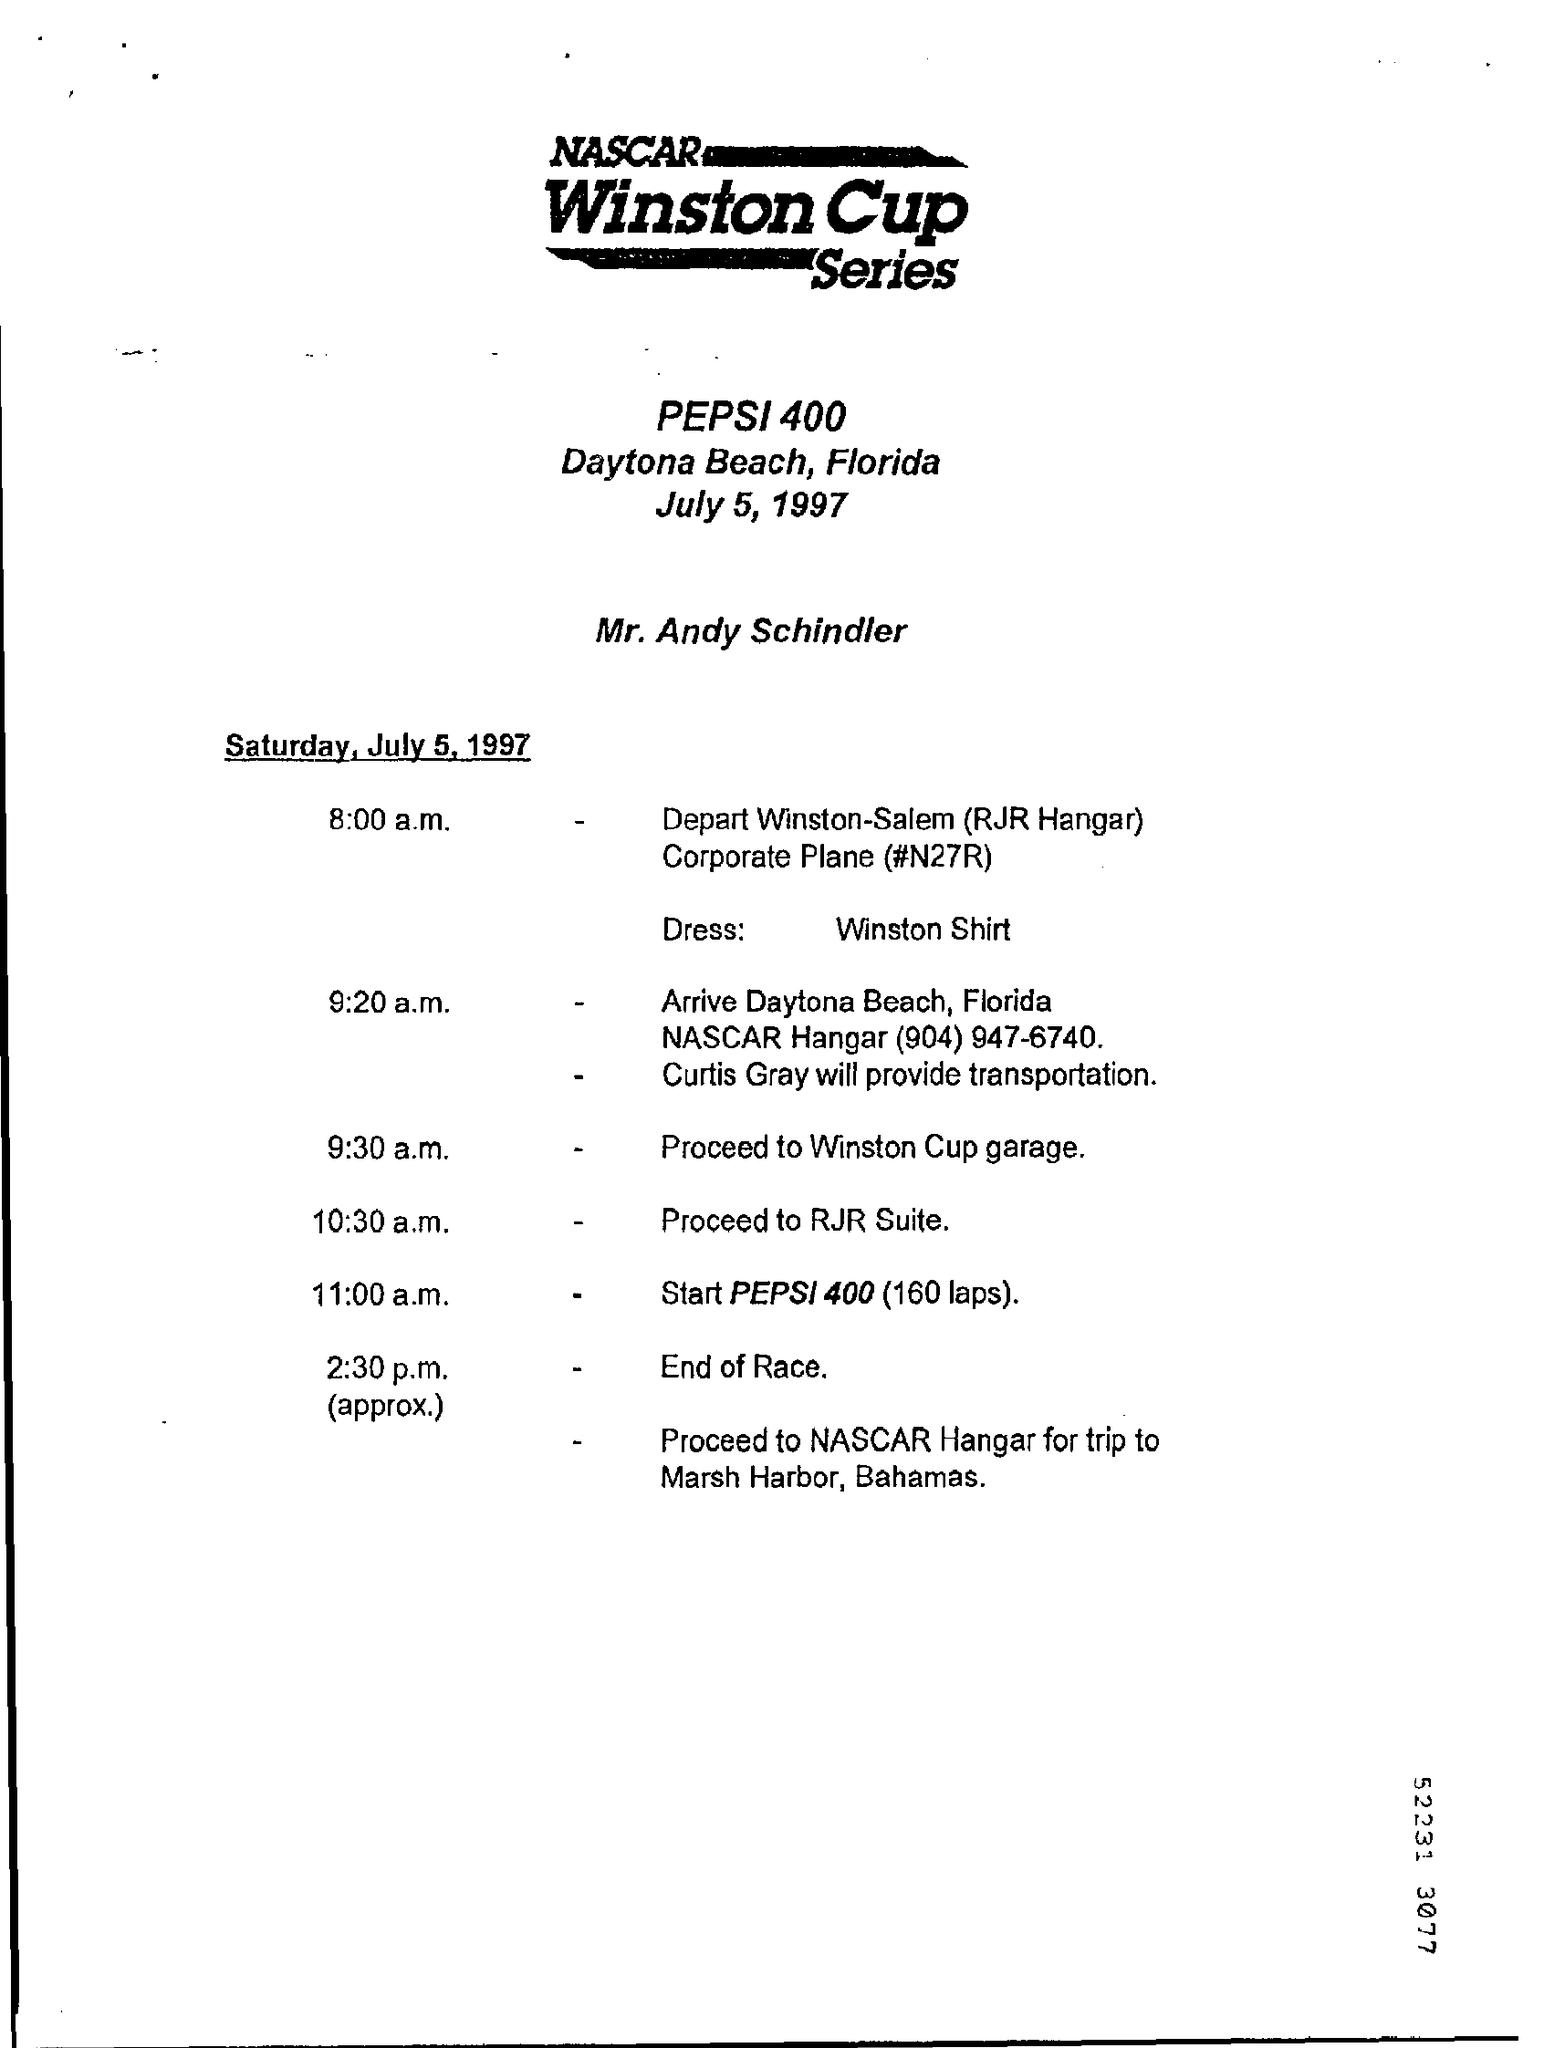What is the document title?
Ensure brevity in your answer.  NASCAR Winston Cup Series. Whose name is given?
Give a very brief answer. Mr. Andy Schindler. What is the dress code?
Make the answer very short. Winston Shirt. What is the event at 11:00 a.m.?
Ensure brevity in your answer.  Start PEPSI 400 (160 laps). Who will provide the transportation to Winston Cup garage?
Ensure brevity in your answer.  Curtis Gray. Where is the race going to be held?
Provide a succinct answer. Daytona Beach. 